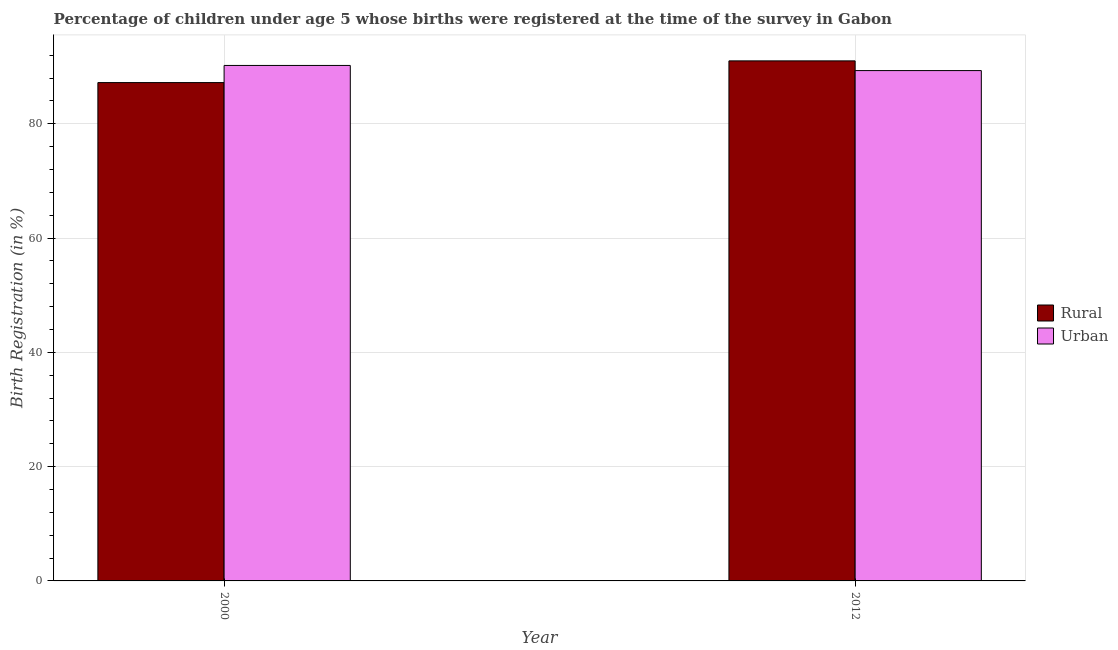How many different coloured bars are there?
Give a very brief answer. 2. How many groups of bars are there?
Your answer should be compact. 2. Are the number of bars on each tick of the X-axis equal?
Ensure brevity in your answer.  Yes. In how many cases, is the number of bars for a given year not equal to the number of legend labels?
Your answer should be compact. 0. What is the urban birth registration in 2012?
Offer a very short reply. 89.3. Across all years, what is the maximum urban birth registration?
Make the answer very short. 90.2. Across all years, what is the minimum rural birth registration?
Ensure brevity in your answer.  87.2. In which year was the rural birth registration maximum?
Your response must be concise. 2012. In which year was the rural birth registration minimum?
Your answer should be compact. 2000. What is the total urban birth registration in the graph?
Offer a terse response. 179.5. What is the difference between the rural birth registration in 2000 and that in 2012?
Ensure brevity in your answer.  -3.8. What is the difference between the rural birth registration in 2000 and the urban birth registration in 2012?
Make the answer very short. -3.8. What is the average rural birth registration per year?
Make the answer very short. 89.1. In the year 2012, what is the difference between the urban birth registration and rural birth registration?
Offer a very short reply. 0. In how many years, is the urban birth registration greater than 60 %?
Your answer should be compact. 2. What is the ratio of the rural birth registration in 2000 to that in 2012?
Offer a terse response. 0.96. In how many years, is the urban birth registration greater than the average urban birth registration taken over all years?
Provide a succinct answer. 1. What does the 2nd bar from the left in 2000 represents?
Provide a succinct answer. Urban. What does the 2nd bar from the right in 2012 represents?
Make the answer very short. Rural. What is the difference between two consecutive major ticks on the Y-axis?
Keep it short and to the point. 20. Does the graph contain grids?
Give a very brief answer. Yes. Where does the legend appear in the graph?
Offer a terse response. Center right. How many legend labels are there?
Offer a very short reply. 2. How are the legend labels stacked?
Your response must be concise. Vertical. What is the title of the graph?
Your answer should be compact. Percentage of children under age 5 whose births were registered at the time of the survey in Gabon. What is the label or title of the X-axis?
Your answer should be compact. Year. What is the label or title of the Y-axis?
Your answer should be compact. Birth Registration (in %). What is the Birth Registration (in %) in Rural in 2000?
Offer a terse response. 87.2. What is the Birth Registration (in %) of Urban in 2000?
Offer a very short reply. 90.2. What is the Birth Registration (in %) of Rural in 2012?
Give a very brief answer. 91. What is the Birth Registration (in %) in Urban in 2012?
Your answer should be compact. 89.3. Across all years, what is the maximum Birth Registration (in %) of Rural?
Your answer should be very brief. 91. Across all years, what is the maximum Birth Registration (in %) of Urban?
Keep it short and to the point. 90.2. Across all years, what is the minimum Birth Registration (in %) of Rural?
Provide a succinct answer. 87.2. Across all years, what is the minimum Birth Registration (in %) of Urban?
Make the answer very short. 89.3. What is the total Birth Registration (in %) of Rural in the graph?
Make the answer very short. 178.2. What is the total Birth Registration (in %) of Urban in the graph?
Offer a terse response. 179.5. What is the difference between the Birth Registration (in %) of Urban in 2000 and that in 2012?
Give a very brief answer. 0.9. What is the average Birth Registration (in %) in Rural per year?
Ensure brevity in your answer.  89.1. What is the average Birth Registration (in %) in Urban per year?
Keep it short and to the point. 89.75. In the year 2012, what is the difference between the Birth Registration (in %) in Rural and Birth Registration (in %) in Urban?
Offer a terse response. 1.7. What is the ratio of the Birth Registration (in %) of Rural in 2000 to that in 2012?
Your response must be concise. 0.96. What is the ratio of the Birth Registration (in %) of Urban in 2000 to that in 2012?
Offer a terse response. 1.01. What is the difference between the highest and the second highest Birth Registration (in %) in Rural?
Your response must be concise. 3.8. What is the difference between the highest and the lowest Birth Registration (in %) of Urban?
Provide a succinct answer. 0.9. 